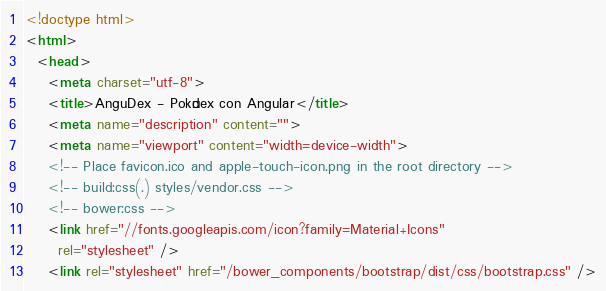Convert code to text. <code><loc_0><loc_0><loc_500><loc_500><_HTML_><!doctype html>
<html>
  <head>
    <meta charset="utf-8">
    <title>AnguDex - Pokédex con Angular</title>
    <meta name="description" content="">
    <meta name="viewport" content="width=device-width">
    <!-- Place favicon.ico and apple-touch-icon.png in the root directory -->
    <!-- build:css(.) styles/vendor.css -->
    <!-- bower:css -->
    <link href="//fonts.googleapis.com/icon?family=Material+Icons"
      rel="stylesheet" />
    <link rel="stylesheet" href="/bower_components/bootstrap/dist/css/bootstrap.css" /></code> 